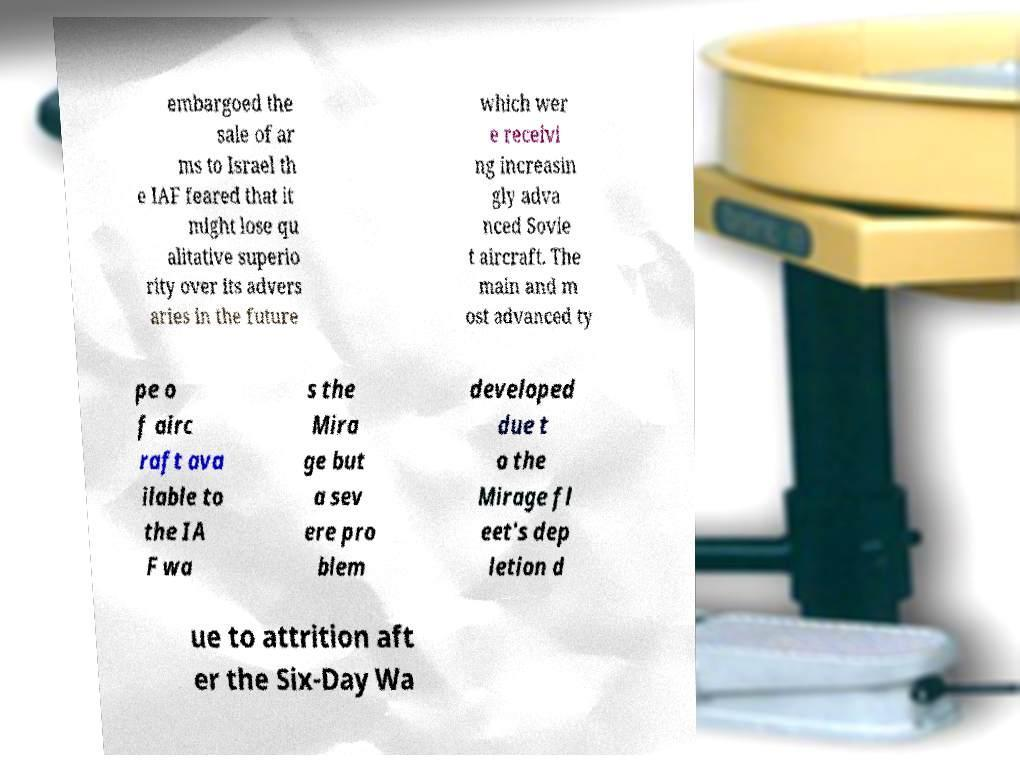Please identify and transcribe the text found in this image. embargoed the sale of ar ms to Israel th e IAF feared that it might lose qu alitative superio rity over its advers aries in the future which wer e receivi ng increasin gly adva nced Sovie t aircraft. The main and m ost advanced ty pe o f airc raft ava ilable to the IA F wa s the Mira ge but a sev ere pro blem developed due t o the Mirage fl eet's dep letion d ue to attrition aft er the Six-Day Wa 